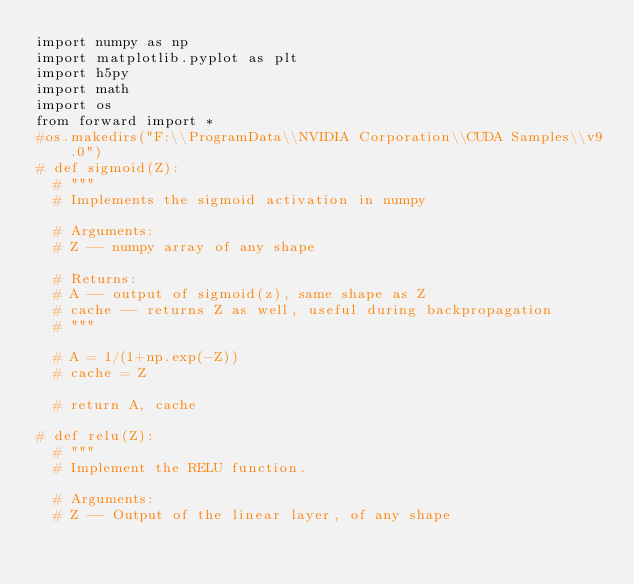Convert code to text. <code><loc_0><loc_0><loc_500><loc_500><_Python_>import numpy as np
import matplotlib.pyplot as plt
import h5py
import math
import os
from forward import *
#os.makedirs("F:\\ProgramData\\NVIDIA Corporation\\CUDA Samples\\v9.0")
# def sigmoid(Z):
	# """
	# Implements the sigmoid activation in numpy
	
	# Arguments:
	# Z -- numpy array of any shape
	
	# Returns:
	# A -- output of sigmoid(z), same shape as Z
	# cache -- returns Z as well, useful during backpropagation
	# """
	
	# A = 1/(1+np.exp(-Z))
	# cache = Z
	
	# return A, cache

# def relu(Z):
	# """
	# Implement the RELU function.

	# Arguments:
	# Z -- Output of the linear layer, of any shape
</code> 